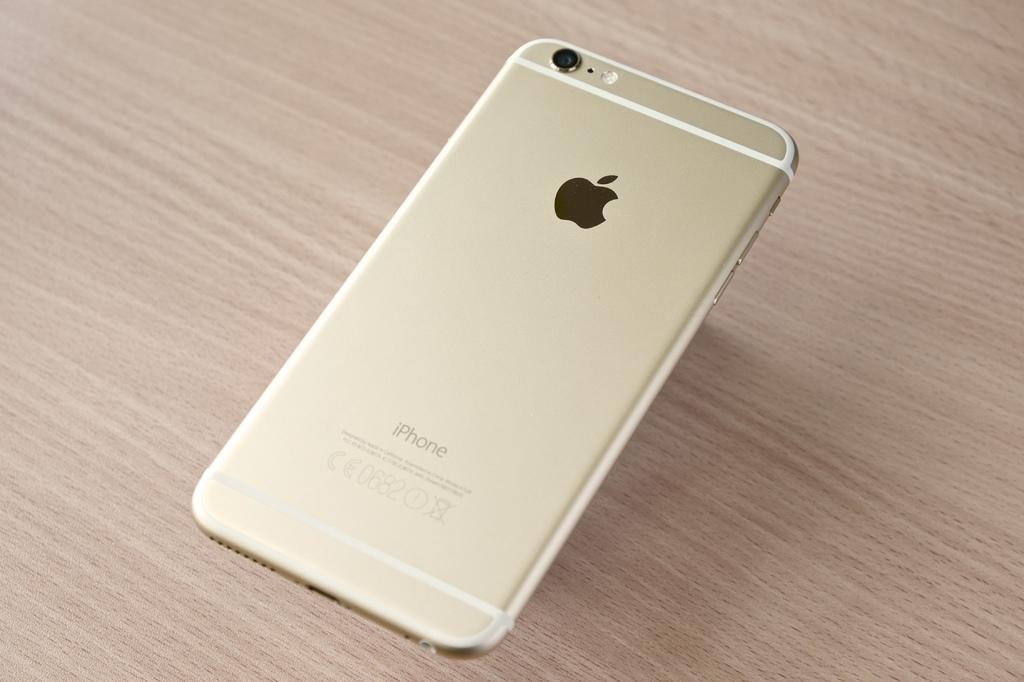<image>
Present a compact description of the photo's key features. The back of an Apple iPhone numbered 0682. 